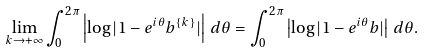<formula> <loc_0><loc_0><loc_500><loc_500>\lim _ { k \to + \infty } \int _ { 0 } ^ { 2 \pi } \left | \log | 1 - e ^ { i \theta } b ^ { \{ k \} } | \right | \, d \theta = \int _ { 0 } ^ { 2 \pi } \left | \log | 1 - e ^ { i \theta } b | \right | \, d \theta .</formula> 